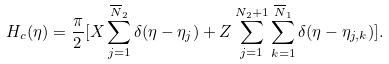<formula> <loc_0><loc_0><loc_500><loc_500>H _ { c } ( \eta ) = \frac { \pi } { 2 } [ X \sum _ { j = 1 } ^ { \overline { N } _ { 2 } } \delta ( \eta - \eta _ { j } ) + Z \sum _ { j = 1 } ^ { N _ { 2 } + 1 } \sum _ { k = 1 } ^ { \overline { N } _ { 1 } } \delta ( \eta - \eta _ { j , k } ) ] .</formula> 